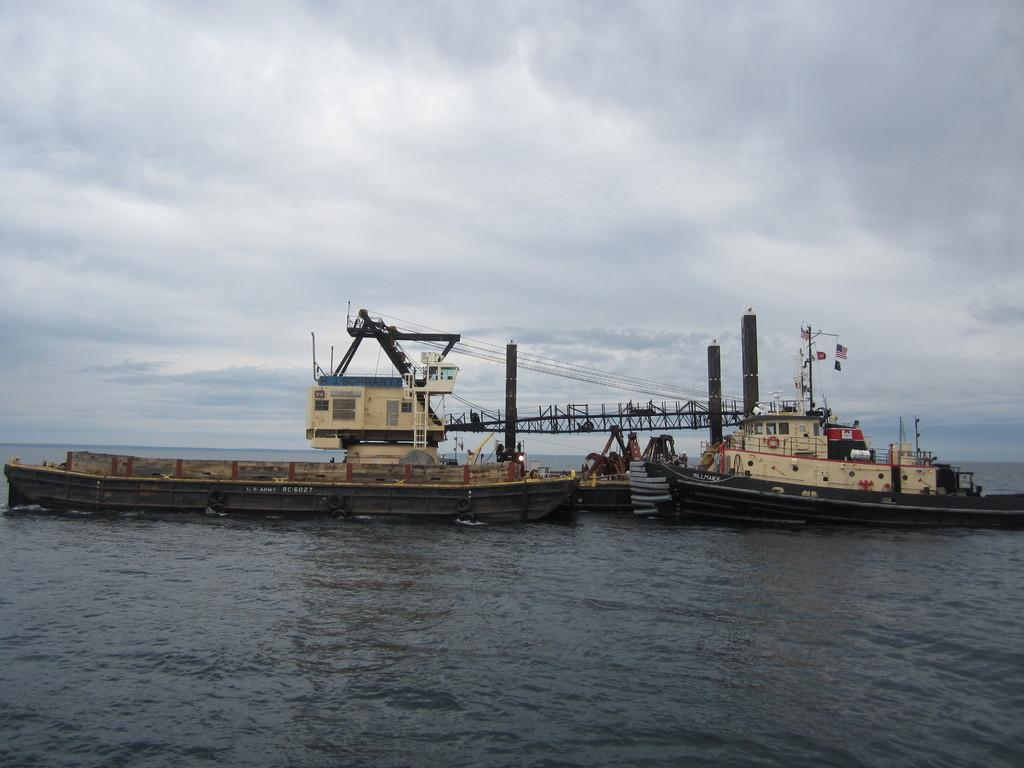What is on the water in the image? There are boats on the water in the image. What else can be seen in the image besides the boats? Poles and wires are visible in the image. How many objects can be counted in the image? There are a few objects in the image. What is visible in the background of the image? The sky is visible in the background of the image. What can be observed about the sky in the image? Clouds are present in the sky. What type of jar is being used to express hate in the image? There is no jar or expression of hate present in the image. 